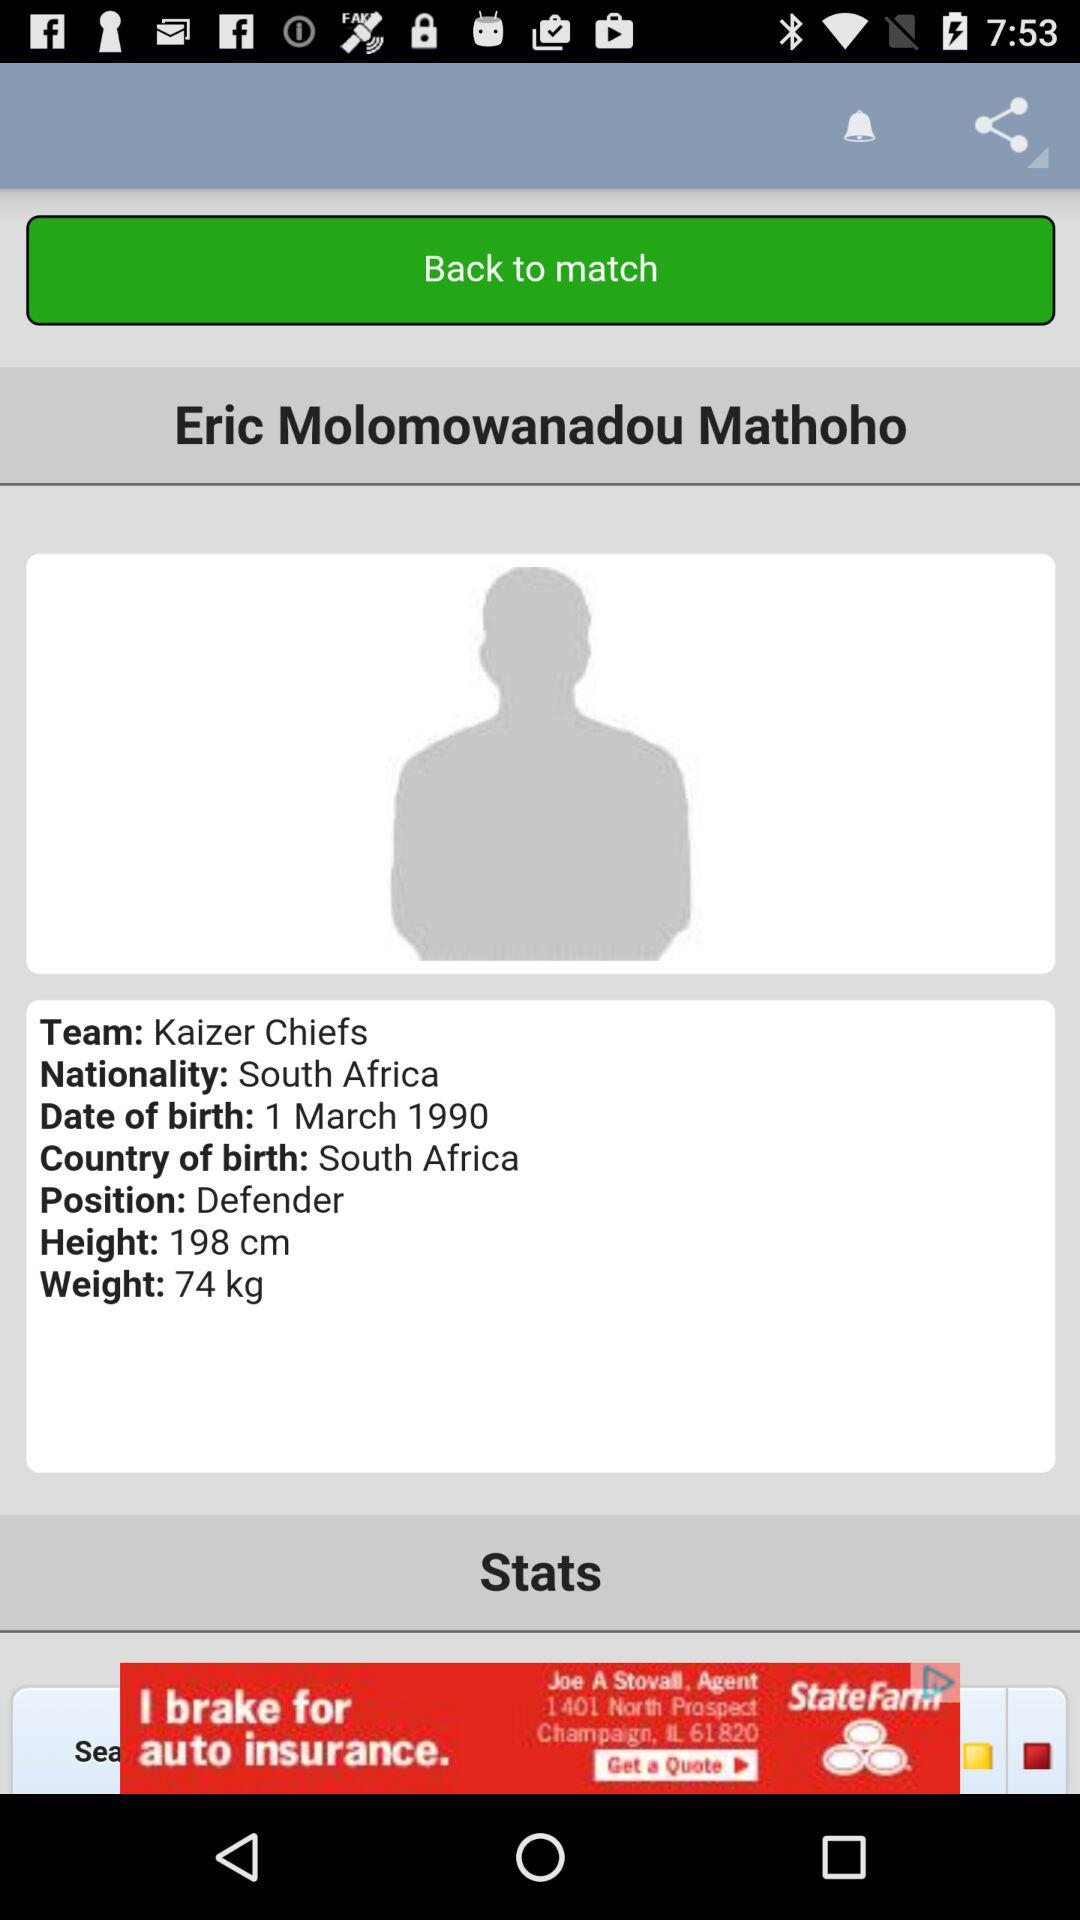What is the date of birth? The date of birth is March 1, 1990. 